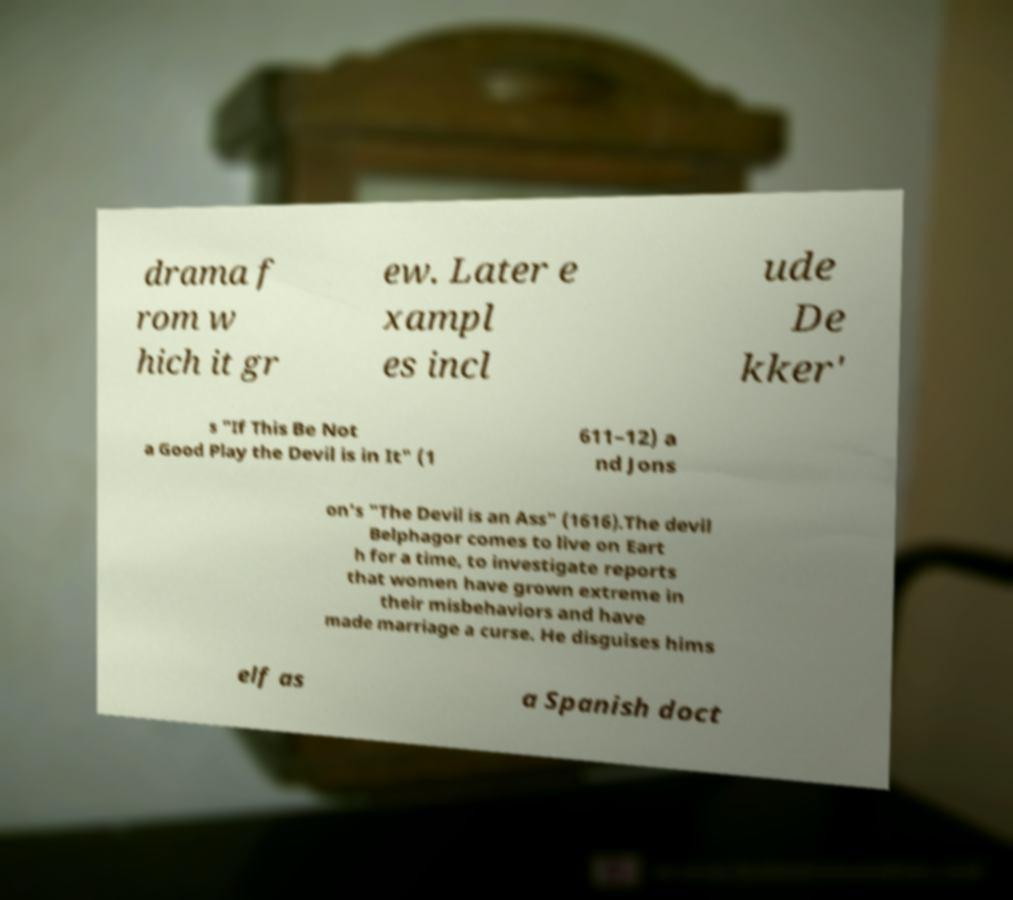There's text embedded in this image that I need extracted. Can you transcribe it verbatim? drama f rom w hich it gr ew. Later e xampl es incl ude De kker' s "If This Be Not a Good Play the Devil is in It" (1 611–12) a nd Jons on's "The Devil is an Ass" (1616).The devil Belphagor comes to live on Eart h for a time, to investigate reports that women have grown extreme in their misbehaviors and have made marriage a curse. He disguises hims elf as a Spanish doct 